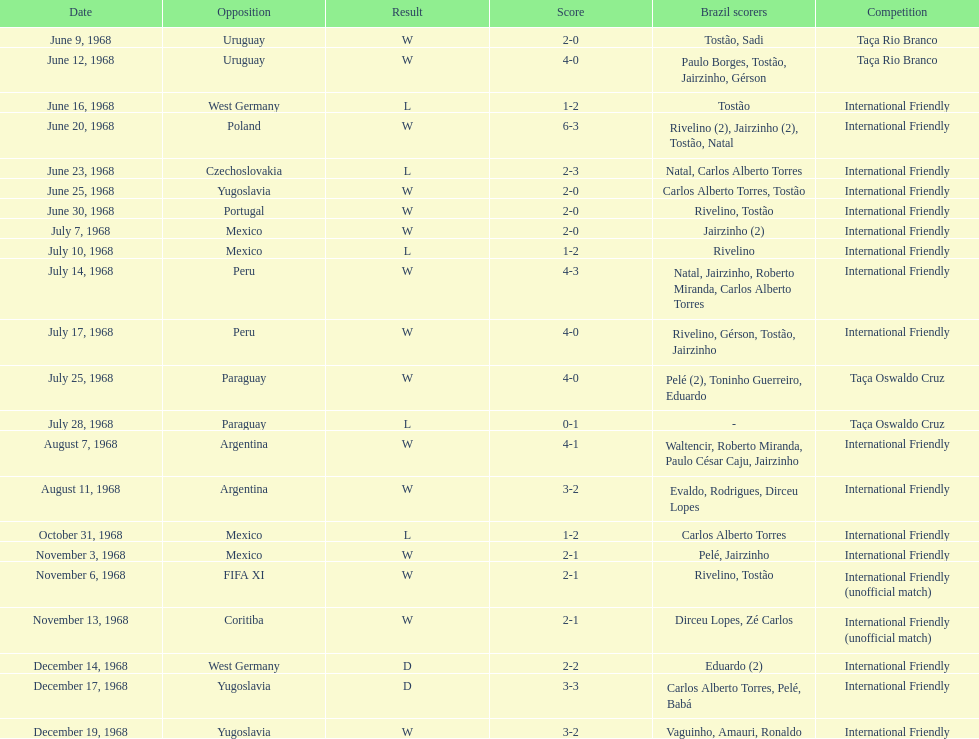The most goals scored by brazil in a game 6. 